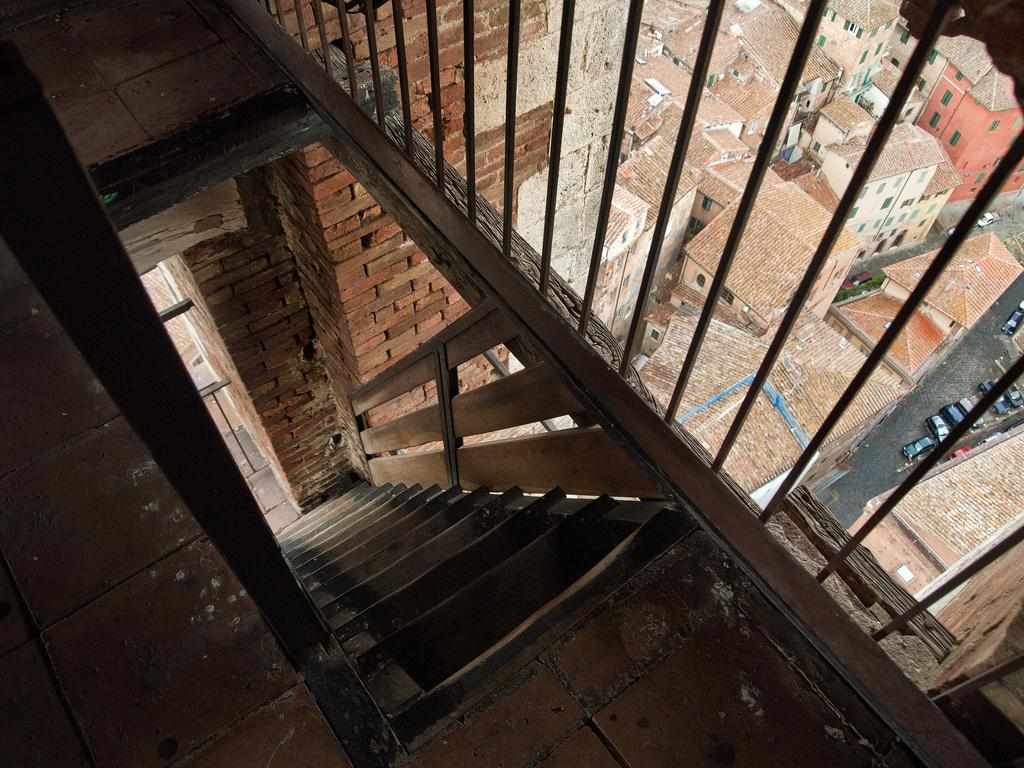What type of architectural feature can be seen in the image? There are steps and a railing in the image. What material is used for the wall in the image? The wall in the image is made of bricks. What is the purpose of the grille in the image? The grille in the image may serve as a barrier or for ventilation. What type of structures are visible in the image? There are buildings in the image. What type of transportation is present in the image? There are vehicles in the image. What is the angle of the elbow in the image? There is no elbow present in the image. What is the weather like in the image? The provided facts do not mention the weather, so it cannot be determined from the image. 